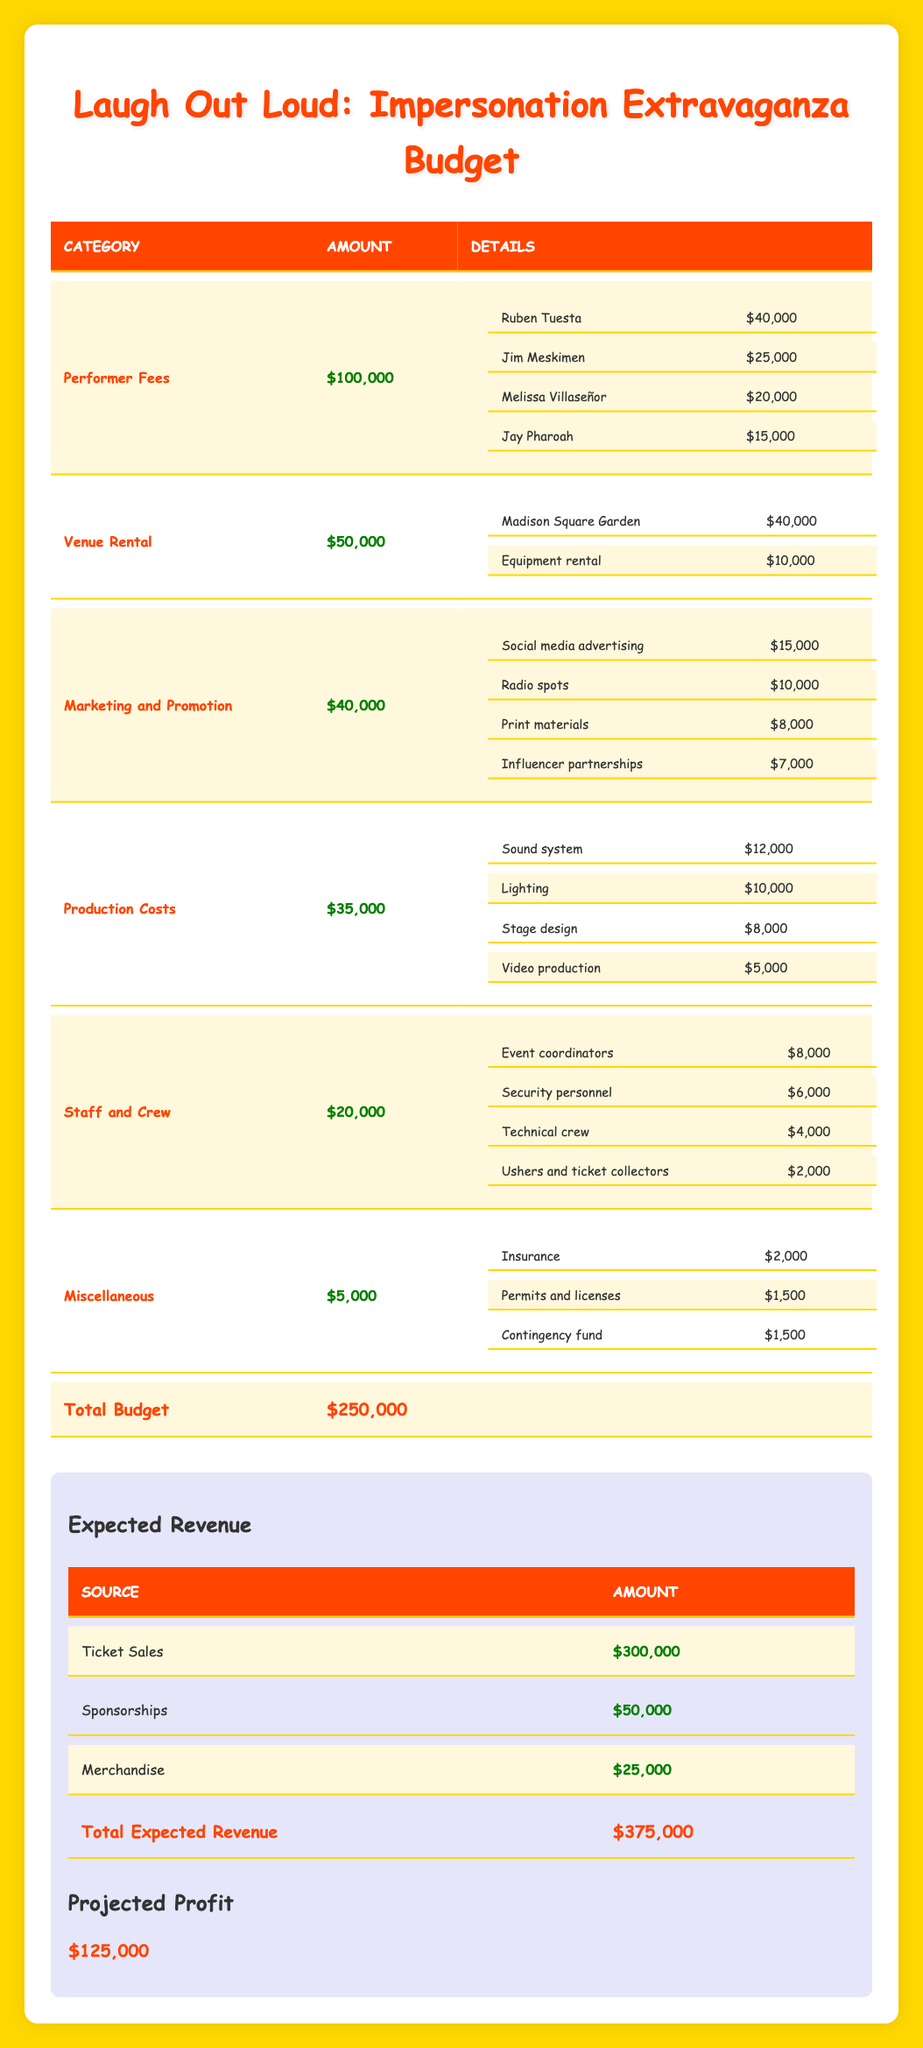What is the total budget allocated for the festival? The total budget is given directly in the table as $250,000.
Answer: $250,000 How much is allocated for performer fees? The performer fees allocation is stated in the table as $100,000.
Answer: $100,000 What is Ruben Tuesta's fee compared to Melissa Villaseñor's fee? Ruben Tuesta's fee is $40,000 and Melissa Villaseñor's fee is $20,000. The comparison shows that Ruben Tuesta's fee is twice that of Melissa Villaseñor's fee.
Answer: Ruben Tuesta's fee is twice Melissa Villaseñor's fee What percentage of the total budget is allocated to venue rental? The venue rental amount is $50,000. To find the percentage of the total budget, we use (50,000 / 250,000) * 100 = 20%.
Answer: 20% Is the revenue from ticket sales greater than the total expected revenue from merchandise? The ticket sales revenue is $300,000, and merchandise revenue is $25,000. Since $300,000 is greater than $25,000, this statement is true.
Answer: Yes Calculate the total costs allocated for marketing and production costs combined. The marketing and production costs are $40,000 and $35,000, respectively. Adding these gives us 40,000 + 35,000 = $75,000.
Answer: $75,000 What is the total amount allocated for staff and miscellaneous costs? The staff costs are $20,000, and the miscellaneous costs are $5,000. Adding these amounts gives 20,000 + 5,000 = $25,000.
Answer: $25,000 How much more is allocated for performer fees than for production costs? Performer fees are $100,000, and production costs are $35,000. The difference is calculated as 100,000 - 35,000 = $65,000.
Answer: $65,000 Is the cost of the sound system higher than the combined costs of lighting and stage design? The sound system cost is $12,000. The costs for lighting and stage design are $10,000 and $8,000, respectively. Their combined cost is 10,000 + 8,000 = $18,000, which is higher than $12,000. Thus, the statement is false.
Answer: No 